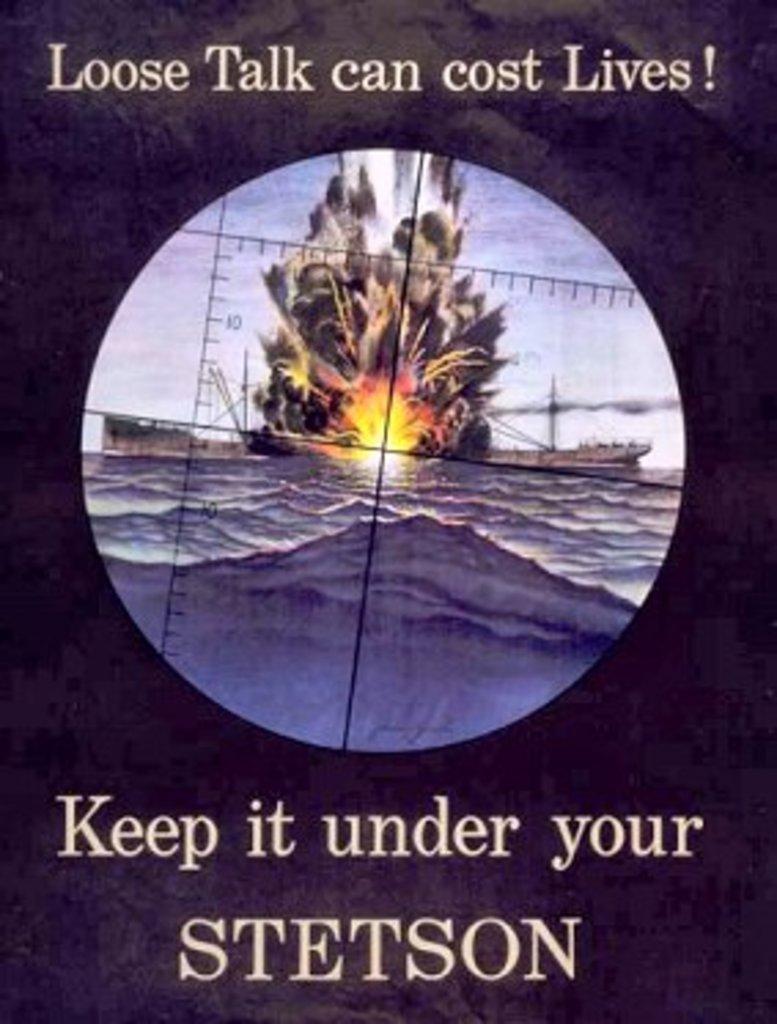What can cost lives?
Provide a short and direct response. Loose talk. 